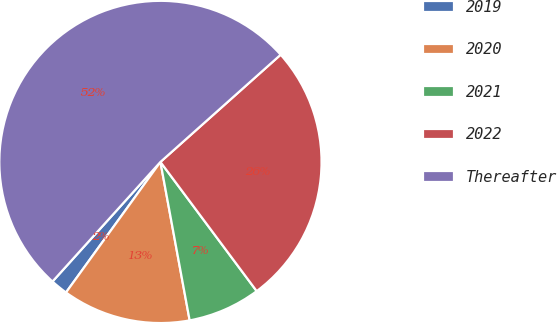<chart> <loc_0><loc_0><loc_500><loc_500><pie_chart><fcel>2019<fcel>2020<fcel>2021<fcel>2022<fcel>Thereafter<nl><fcel>1.72%<fcel>12.87%<fcel>7.29%<fcel>26.4%<fcel>51.72%<nl></chart> 